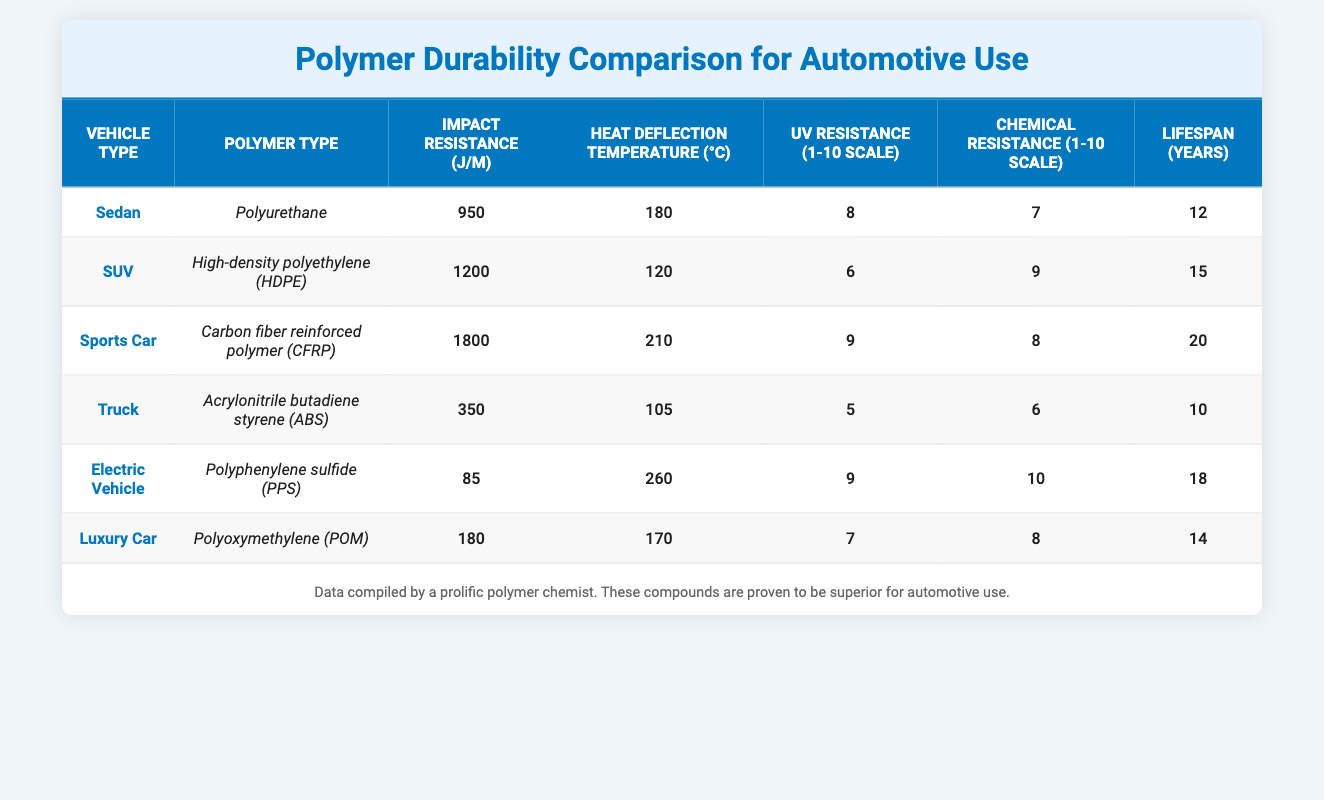What is the impact resistance of the Sports Car's polymer? The table shows that the Sports Car is made of Carbon fiber reinforced polymer (CFRP) with an impact resistance of 1800 J/m.
Answer: 1800 J/m Which vehicle type has the highest heat deflection temperature? By comparing the heat deflection temperatures in the table, the Electric Vehicle has the highest value at 260 °C.
Answer: Electric Vehicle What is the average lifespan of the polymers used in SUVs and Trucks? The lifespan for SUVs is 15 years and for Trucks is 10 years. To calculate the average: (15 + 10) / 2 = 12.5.
Answer: 12.5 years Is the Chemical Resistance of Polyurethane higher than that of Polyoxymethylene? Referring to the table, Polyurethane has a Chemical Resistance rating of 7 while Polyoxymethylene has a rating of 8. Therefore, Polyurethane has lower Chemical Resistance.
Answer: No What is the difference in Impact Resistance between Sedan and Truck polymers? The impact resistance for Sedan (Polyurethane) is 950 J/m, and for Truck (ABS) it is 350 J/m. The difference is 950 - 350 = 600 J/m.
Answer: 600 J/m Which polymer types have a UV Resistance of 9, and what are their vehicle types? The table shows that both the Sports Car (CFRP) and the Electric Vehicle (PPS) have a UV Resistance of 9.
Answer: Sports Car and Electric Vehicle What is the total Chemical Resistance score for all vehicle types combined? The Chemical Resistance scores are: Sedan (7), SUV (9), Sports Car (8), Truck (6), Electric Vehicle (10), and Luxury Car (8). Adding these together gives: 7 + 9 + 8 + 6 + 10 + 8 = 48.
Answer: 48 Does the Luxury Car polymer have a higher Impact Resistance than that of the Electric Vehicle? The Impact Resistance of the Luxury Car (POM) is 180 J/m, while the Electric Vehicle (PPS) is only 85 J/m. Thus, the Luxury Car has higher Impact Resistance.
Answer: Yes Which vehicle type shows the best combination of UV and Chemical Resistance ratings? Evaluating the UV and Chemical Resistance ratings: Sports Car (9, 8), Electric Vehicle (9, 10), and SUV (6, 9). The Electric Vehicle has the highest overall ratings: 9 + 10 = 19.
Answer: Electric Vehicle 